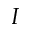<formula> <loc_0><loc_0><loc_500><loc_500>I</formula> 